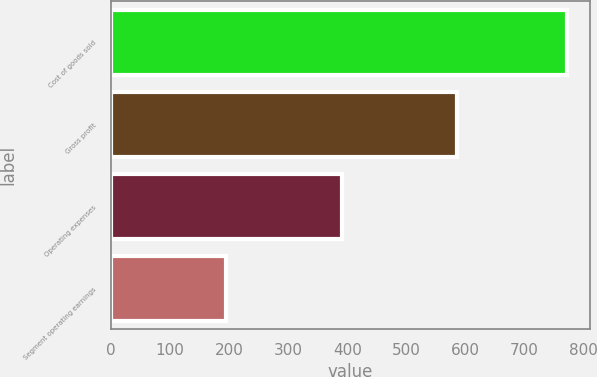<chart> <loc_0><loc_0><loc_500><loc_500><bar_chart><fcel>Cost of goods sold<fcel>Gross profit<fcel>Operating expenses<fcel>Segment operating earnings<nl><fcel>772.6<fcel>585.8<fcel>391.2<fcel>194.6<nl></chart> 